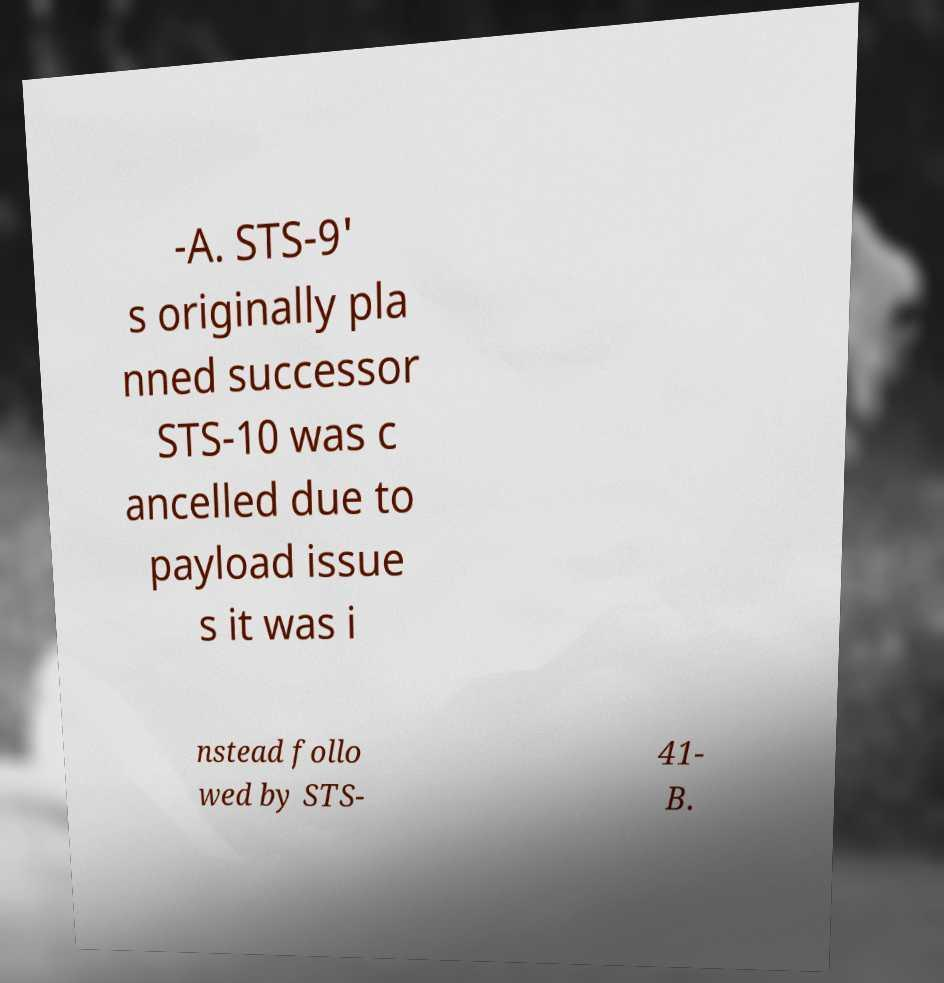Can you read and provide the text displayed in the image?This photo seems to have some interesting text. Can you extract and type it out for me? -A. STS-9' s originally pla nned successor STS-10 was c ancelled due to payload issue s it was i nstead follo wed by STS- 41- B. 